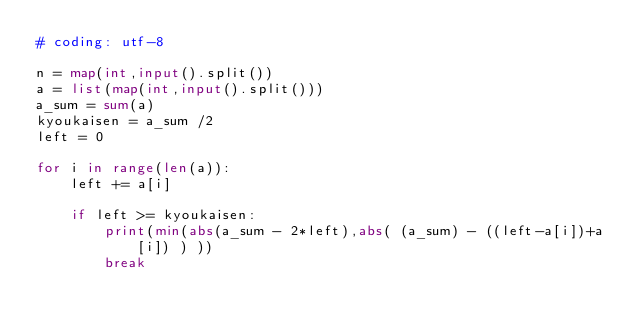<code> <loc_0><loc_0><loc_500><loc_500><_Python_># coding: utf-8

n = map(int,input().split())
a = list(map(int,input().split()))
a_sum = sum(a)
kyoukaisen = a_sum /2
left = 0

for i in range(len(a)):
    left += a[i]
    
    if left >= kyoukaisen:
        print(min(abs(a_sum - 2*left),abs( (a_sum) - ((left-a[i])+a[i]) ) ))
        break</code> 